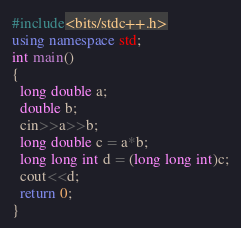<code> <loc_0><loc_0><loc_500><loc_500><_C++_>#include<bits/stdc++.h>
using namespace std;
int main()
{
  long double a;
  double b;
  cin>>a>>b;
  long double c = a*b;
  long long int d = (long long int)c;
  cout<<d;
  return 0;
}
</code> 